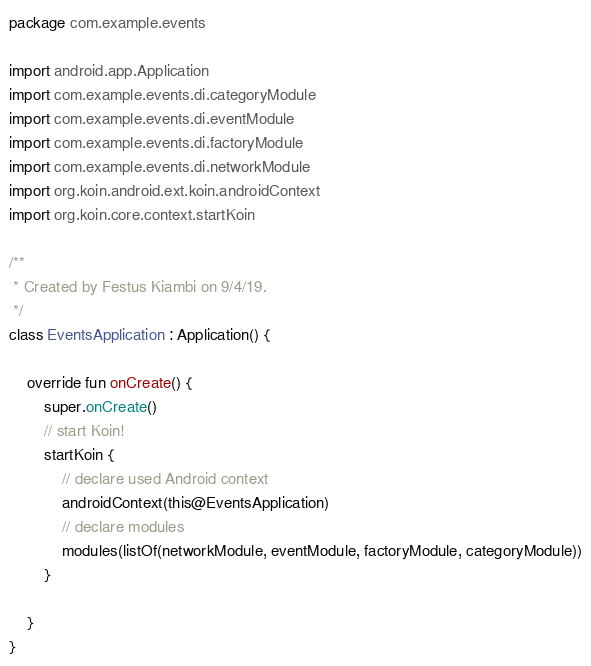Convert code to text. <code><loc_0><loc_0><loc_500><loc_500><_Kotlin_>package com.example.events

import android.app.Application
import com.example.events.di.categoryModule
import com.example.events.di.eventModule
import com.example.events.di.factoryModule
import com.example.events.di.networkModule
import org.koin.android.ext.koin.androidContext
import org.koin.core.context.startKoin

/**
 * Created by Festus Kiambi on 9/4/19.
 */
class EventsApplication : Application() {

    override fun onCreate() {
        super.onCreate()
        // start Koin!
        startKoin {
            // declare used Android context
            androidContext(this@EventsApplication)
            // declare modules
            modules(listOf(networkModule, eventModule, factoryModule, categoryModule))
        }

    }
}</code> 